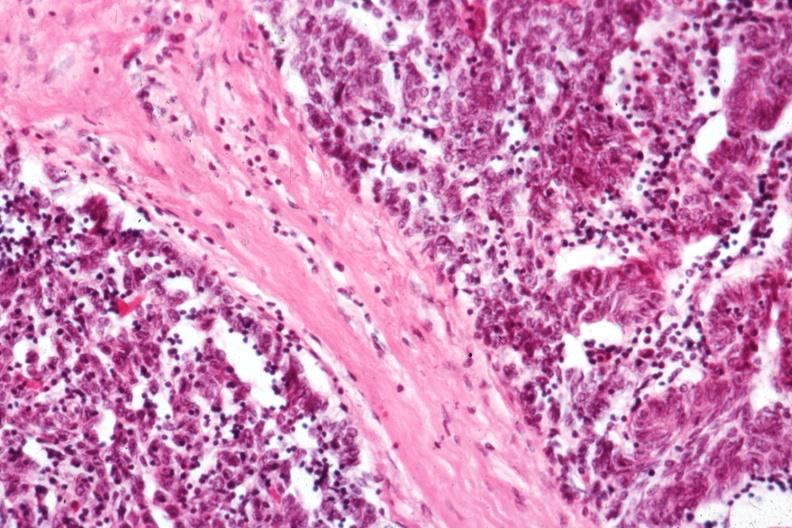what does this image show?
Answer the question using a single word or phrase. Predominant epithelial component 